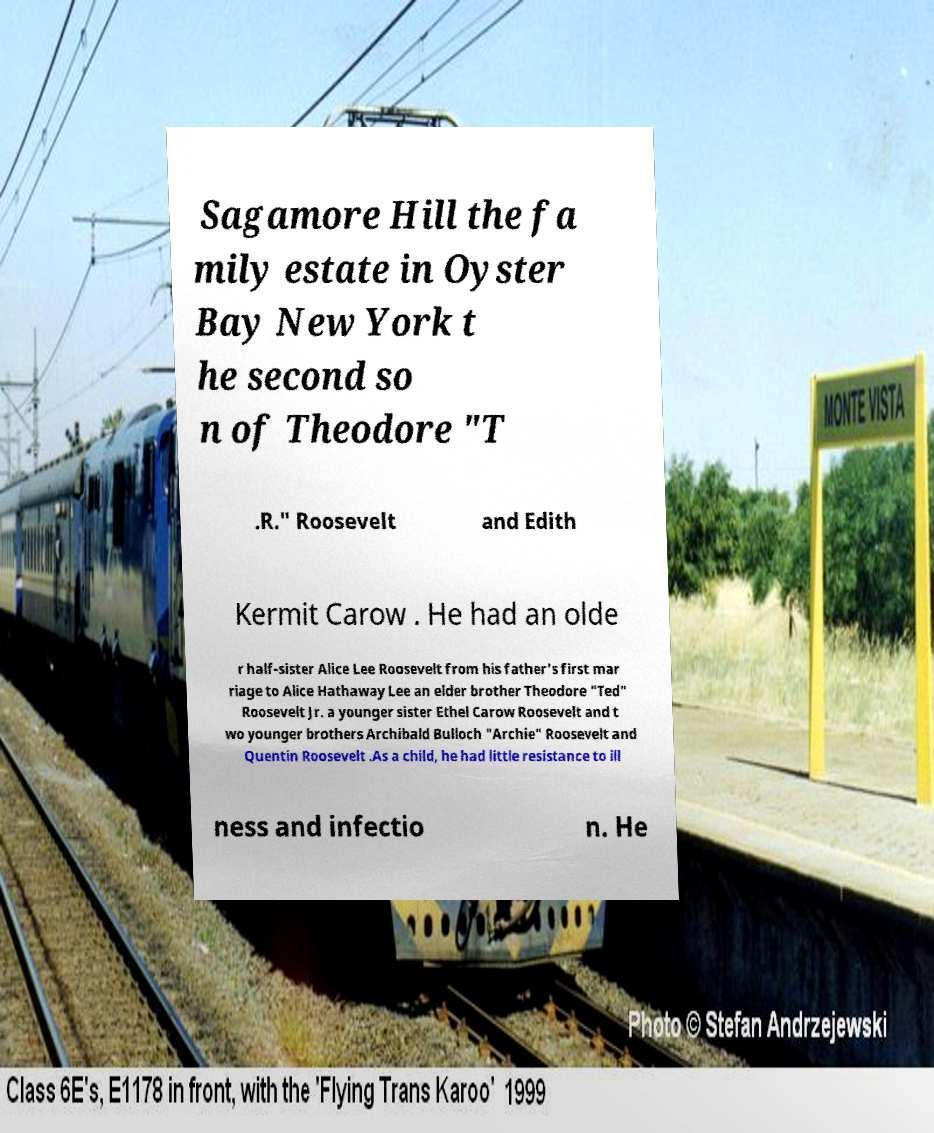I need the written content from this picture converted into text. Can you do that? Sagamore Hill the fa mily estate in Oyster Bay New York t he second so n of Theodore "T .R." Roosevelt and Edith Kermit Carow . He had an olde r half-sister Alice Lee Roosevelt from his father's first mar riage to Alice Hathaway Lee an elder brother Theodore "Ted" Roosevelt Jr. a younger sister Ethel Carow Roosevelt and t wo younger brothers Archibald Bulloch "Archie" Roosevelt and Quentin Roosevelt .As a child, he had little resistance to ill ness and infectio n. He 